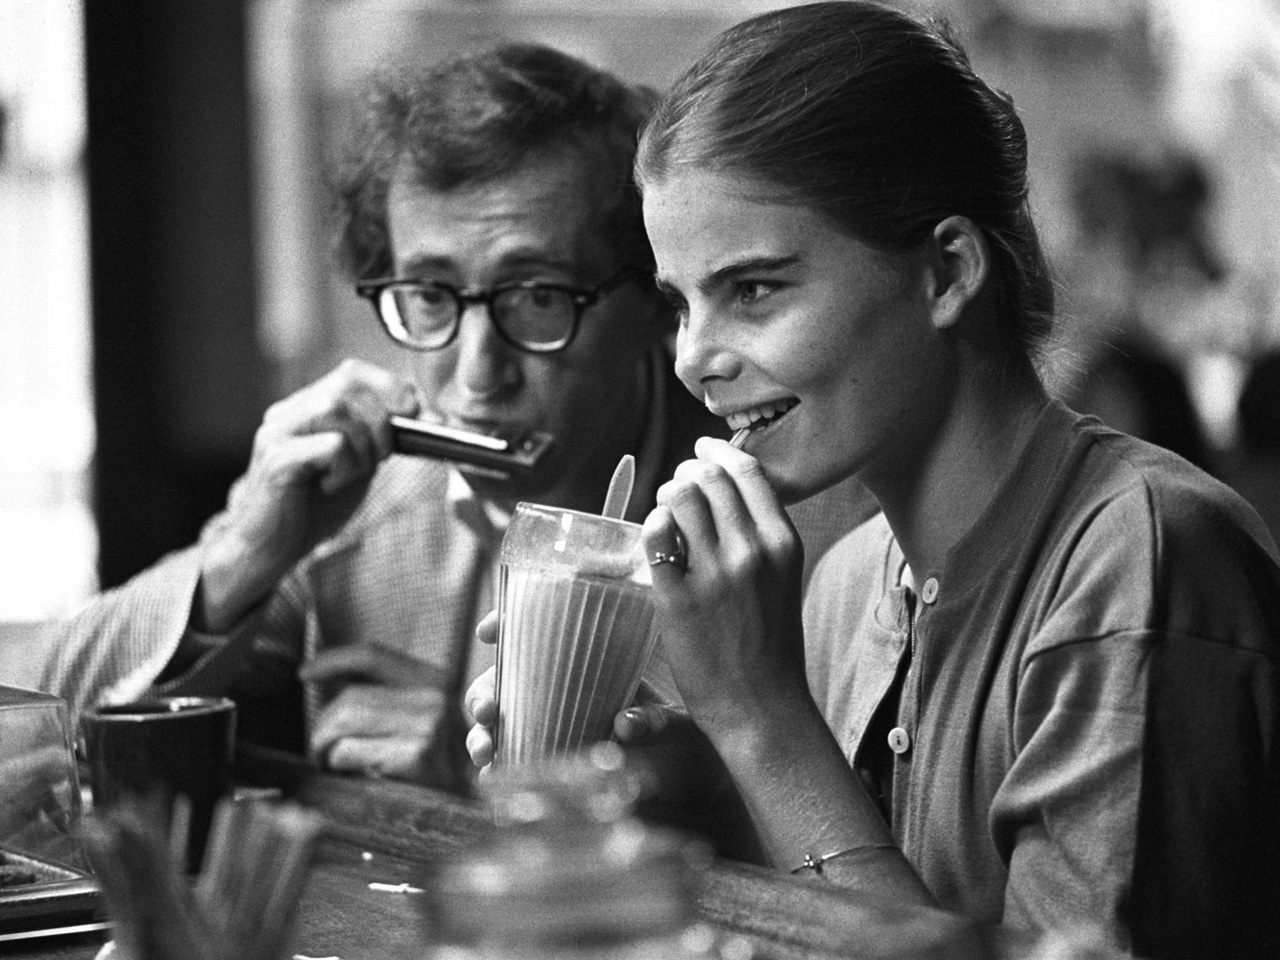What might the conversation between them sound like? Their conversation might be filled with light-hearted banter, interspersed with deep, contemplative discussions about life, art, and creativity. They might share personal anecdotes, inspiring each other with tales of past experiences and dreams for the future. The person on the left could be reminiscing about a tune they played years ago, while the person on the right reflects on a scene from a novel they’re working on. There’s a harmonious blend of laughter, curiosity, and mutual encouragement underlying their dialogue. If they were characters in a novel, what would their storyline be? If they were characters in a novel, their storyline could be a beautifully woven tapestry of serendipitous encounters and creative pursuits. Meeting by chance in a bustling city, they realize their shared passion for music and storytelling. Their journey is marked by collaborative projects, adventures across picturesque locales, and the deepening of their bond through trials and triumphs. The story would explore themes of friendship, the pursuit of artistic dreams, and the magic found in everyday moments, culminating in a heartfelt celebration of life’s simple yet profound connections. Imagine they are time travelers who met in this moment. What adventures might they go on? As time travelers, their adventures span both historical epochs and futuristic realms. Together, they navigate the bustling streets of Renaissance Florence, exchanging ideas with artists like Leonardo da Vinci. They then leap to the roaring 1920s of Paris, dancing through jazz clubs and sharing poetry with the Lost Generation. Their journey continues to the distant future, where they explore floating cities and meet robotic companions. Along the way, they weave their experiences into a timeless tapestry of music and stories, forever bound by the unique convergence of their paths in that one cafe moment. 